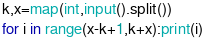Convert code to text. <code><loc_0><loc_0><loc_500><loc_500><_Python_>k,x=map(int,input().split())
for i in range(x-k+1,k+x):print(i)</code> 